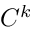<formula> <loc_0><loc_0><loc_500><loc_500>C ^ { k }</formula> 